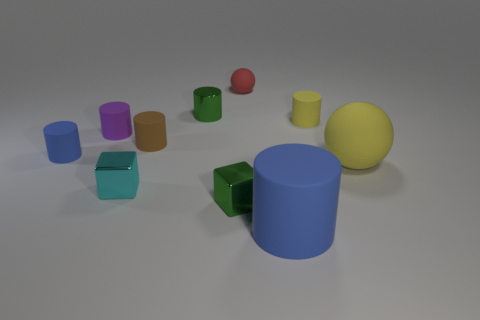What size is the blue object that is on the right side of the small brown rubber object?
Provide a short and direct response. Large. Is the brown matte thing the same shape as the red rubber thing?
Keep it short and to the point. No. How many small things are either purple objects or purple rubber blocks?
Offer a terse response. 1. There is a cyan cube; are there any tiny blue rubber things on the right side of it?
Ensure brevity in your answer.  No. Are there the same number of large spheres behind the big blue rubber cylinder and tiny red matte spheres?
Offer a very short reply. Yes. What size is the yellow matte thing that is the same shape as the red thing?
Your answer should be very brief. Large. There is a tiny purple rubber thing; is its shape the same as the small matte object on the right side of the big blue rubber thing?
Ensure brevity in your answer.  Yes. How big is the metallic thing behind the small shiny block behind the green shiny cube?
Offer a terse response. Small. Is the number of objects that are in front of the small yellow object the same as the number of large yellow rubber balls behind the cyan shiny object?
Your answer should be very brief. No. What is the color of the shiny thing that is the same shape as the small purple matte thing?
Your answer should be very brief. Green. 